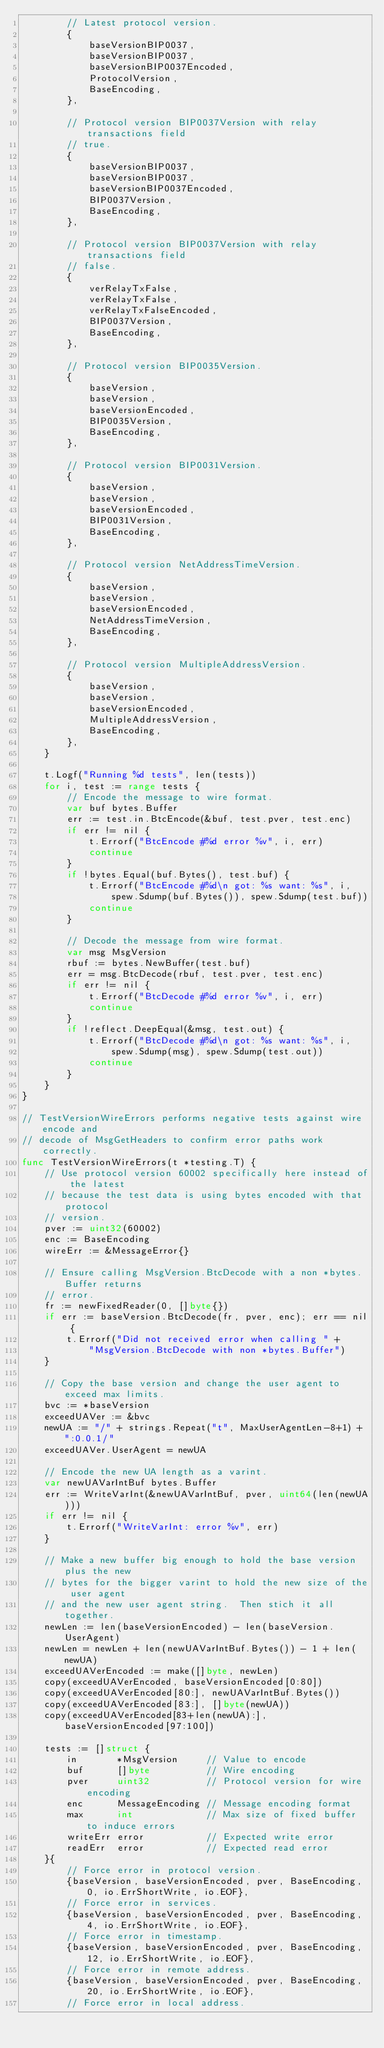Convert code to text. <code><loc_0><loc_0><loc_500><loc_500><_Go_>		// Latest protocol version.
		{
			baseVersionBIP0037,
			baseVersionBIP0037,
			baseVersionBIP0037Encoded,
			ProtocolVersion,
			BaseEncoding,
		},

		// Protocol version BIP0037Version with relay transactions field
		// true.
		{
			baseVersionBIP0037,
			baseVersionBIP0037,
			baseVersionBIP0037Encoded,
			BIP0037Version,
			BaseEncoding,
		},

		// Protocol version BIP0037Version with relay transactions field
		// false.
		{
			verRelayTxFalse,
			verRelayTxFalse,
			verRelayTxFalseEncoded,
			BIP0037Version,
			BaseEncoding,
		},

		// Protocol version BIP0035Version.
		{
			baseVersion,
			baseVersion,
			baseVersionEncoded,
			BIP0035Version,
			BaseEncoding,
		},

		// Protocol version BIP0031Version.
		{
			baseVersion,
			baseVersion,
			baseVersionEncoded,
			BIP0031Version,
			BaseEncoding,
		},

		// Protocol version NetAddressTimeVersion.
		{
			baseVersion,
			baseVersion,
			baseVersionEncoded,
			NetAddressTimeVersion,
			BaseEncoding,
		},

		// Protocol version MultipleAddressVersion.
		{
			baseVersion,
			baseVersion,
			baseVersionEncoded,
			MultipleAddressVersion,
			BaseEncoding,
		},
	}

	t.Logf("Running %d tests", len(tests))
	for i, test := range tests {
		// Encode the message to wire format.
		var buf bytes.Buffer
		err := test.in.BtcEncode(&buf, test.pver, test.enc)
		if err != nil {
			t.Errorf("BtcEncode #%d error %v", i, err)
			continue
		}
		if !bytes.Equal(buf.Bytes(), test.buf) {
			t.Errorf("BtcEncode #%d\n got: %s want: %s", i,
				spew.Sdump(buf.Bytes()), spew.Sdump(test.buf))
			continue
		}

		// Decode the message from wire format.
		var msg MsgVersion
		rbuf := bytes.NewBuffer(test.buf)
		err = msg.BtcDecode(rbuf, test.pver, test.enc)
		if err != nil {
			t.Errorf("BtcDecode #%d error %v", i, err)
			continue
		}
		if !reflect.DeepEqual(&msg, test.out) {
			t.Errorf("BtcDecode #%d\n got: %s want: %s", i,
				spew.Sdump(msg), spew.Sdump(test.out))
			continue
		}
	}
}

// TestVersionWireErrors performs negative tests against wire encode and
// decode of MsgGetHeaders to confirm error paths work correctly.
func TestVersionWireErrors(t *testing.T) {
	// Use protocol version 60002 specifically here instead of the latest
	// because the test data is using bytes encoded with that protocol
	// version.
	pver := uint32(60002)
	enc := BaseEncoding
	wireErr := &MessageError{}

	// Ensure calling MsgVersion.BtcDecode with a non *bytes.Buffer returns
	// error.
	fr := newFixedReader(0, []byte{})
	if err := baseVersion.BtcDecode(fr, pver, enc); err == nil {
		t.Errorf("Did not received error when calling " +
			"MsgVersion.BtcDecode with non *bytes.Buffer")
	}

	// Copy the base version and change the user agent to exceed max limits.
	bvc := *baseVersion
	exceedUAVer := &bvc
	newUA := "/" + strings.Repeat("t", MaxUserAgentLen-8+1) + ":0.0.1/"
	exceedUAVer.UserAgent = newUA

	// Encode the new UA length as a varint.
	var newUAVarIntBuf bytes.Buffer
	err := WriteVarInt(&newUAVarIntBuf, pver, uint64(len(newUA)))
	if err != nil {
		t.Errorf("WriteVarInt: error %v", err)
	}

	// Make a new buffer big enough to hold the base version plus the new
	// bytes for the bigger varint to hold the new size of the user agent
	// and the new user agent string.  Then stich it all together.
	newLen := len(baseVersionEncoded) - len(baseVersion.UserAgent)
	newLen = newLen + len(newUAVarIntBuf.Bytes()) - 1 + len(newUA)
	exceedUAVerEncoded := make([]byte, newLen)
	copy(exceedUAVerEncoded, baseVersionEncoded[0:80])
	copy(exceedUAVerEncoded[80:], newUAVarIntBuf.Bytes())
	copy(exceedUAVerEncoded[83:], []byte(newUA))
	copy(exceedUAVerEncoded[83+len(newUA):], baseVersionEncoded[97:100])

	tests := []struct {
		in       *MsgVersion     // Value to encode
		buf      []byte          // Wire encoding
		pver     uint32          // Protocol version for wire encoding
		enc      MessageEncoding // Message encoding format
		max      int             // Max size of fixed buffer to induce errors
		writeErr error           // Expected write error
		readErr  error           // Expected read error
	}{
		// Force error in protocol version.
		{baseVersion, baseVersionEncoded, pver, BaseEncoding, 0, io.ErrShortWrite, io.EOF},
		// Force error in services.
		{baseVersion, baseVersionEncoded, pver, BaseEncoding, 4, io.ErrShortWrite, io.EOF},
		// Force error in timestamp.
		{baseVersion, baseVersionEncoded, pver, BaseEncoding, 12, io.ErrShortWrite, io.EOF},
		// Force error in remote address.
		{baseVersion, baseVersionEncoded, pver, BaseEncoding, 20, io.ErrShortWrite, io.EOF},
		// Force error in local address.</code> 